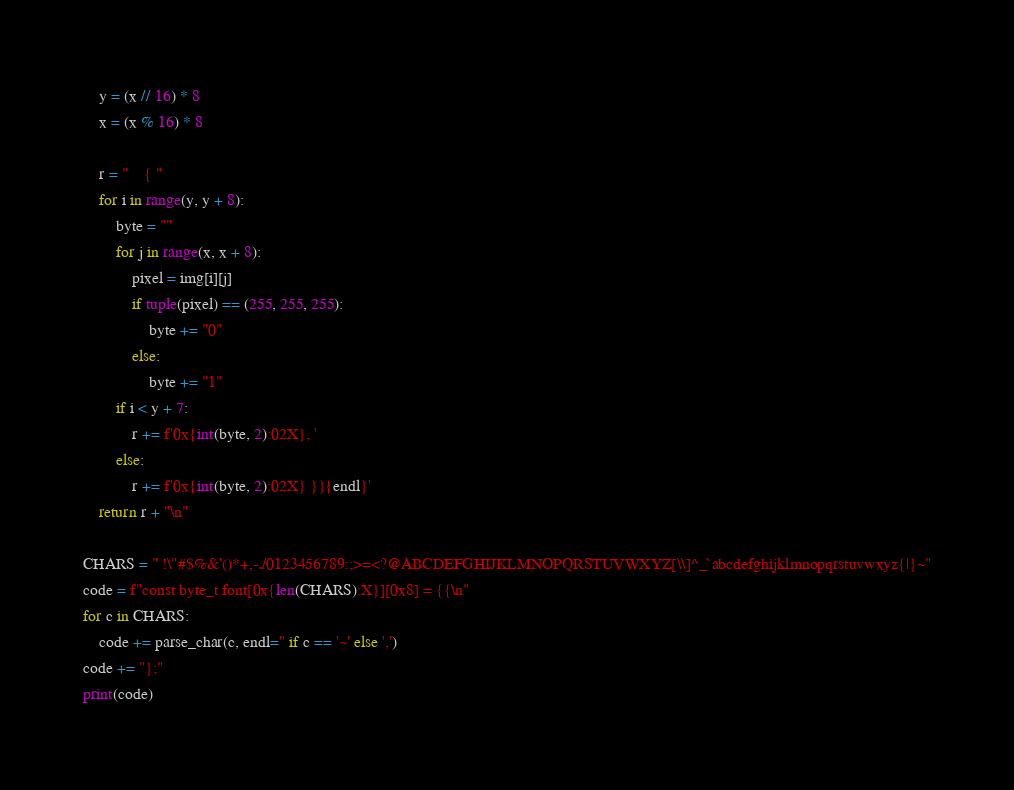<code> <loc_0><loc_0><loc_500><loc_500><_Python_>    y = (x // 16) * 8
    x = (x % 16) * 8

    r = "    { "
    for i in range(y, y + 8):
        byte = ""
        for j in range(x, x + 8):
            pixel = img[i][j]
            if tuple(pixel) == (255, 255, 255):
                byte += "0"
            else:
                byte += "1"
        if i < y + 7:
            r += f'0x{int(byte, 2):02X}, '
        else:
            r += f'0x{int(byte, 2):02X} }}{endl}'
    return r + "\n"

CHARS = " !\"#$%&'()*+,-./0123456789:;>=<?@ABCDEFGHIJKLMNOPQRSTUVWXYZ[\\]^_`abcdefghijklmnopqrstuvwxyz{|}~"
code = f"const byte_t font[0x{len(CHARS):X}][0x8] = {{\n"
for c in CHARS:
    code += parse_char(c, endl='' if c == '~' else ',')
code += "};"
print(code)
</code> 